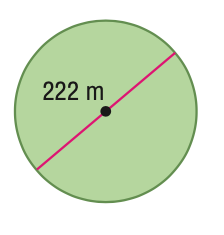Question: Find the area of the circle. Round to the nearest tenth.
Choices:
A. 348.7
B. 697.4
C. 38707.6
D. 154830.3
Answer with the letter. Answer: C 